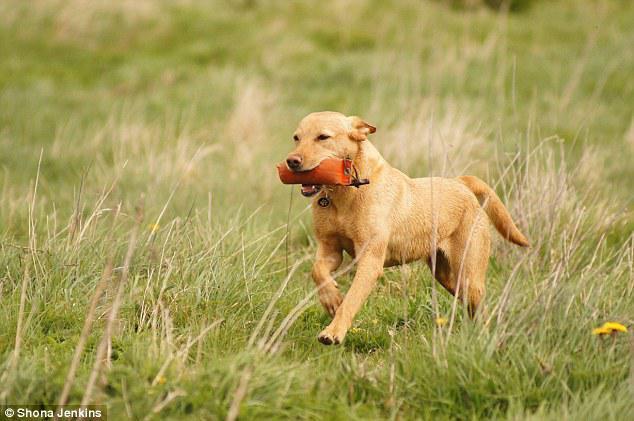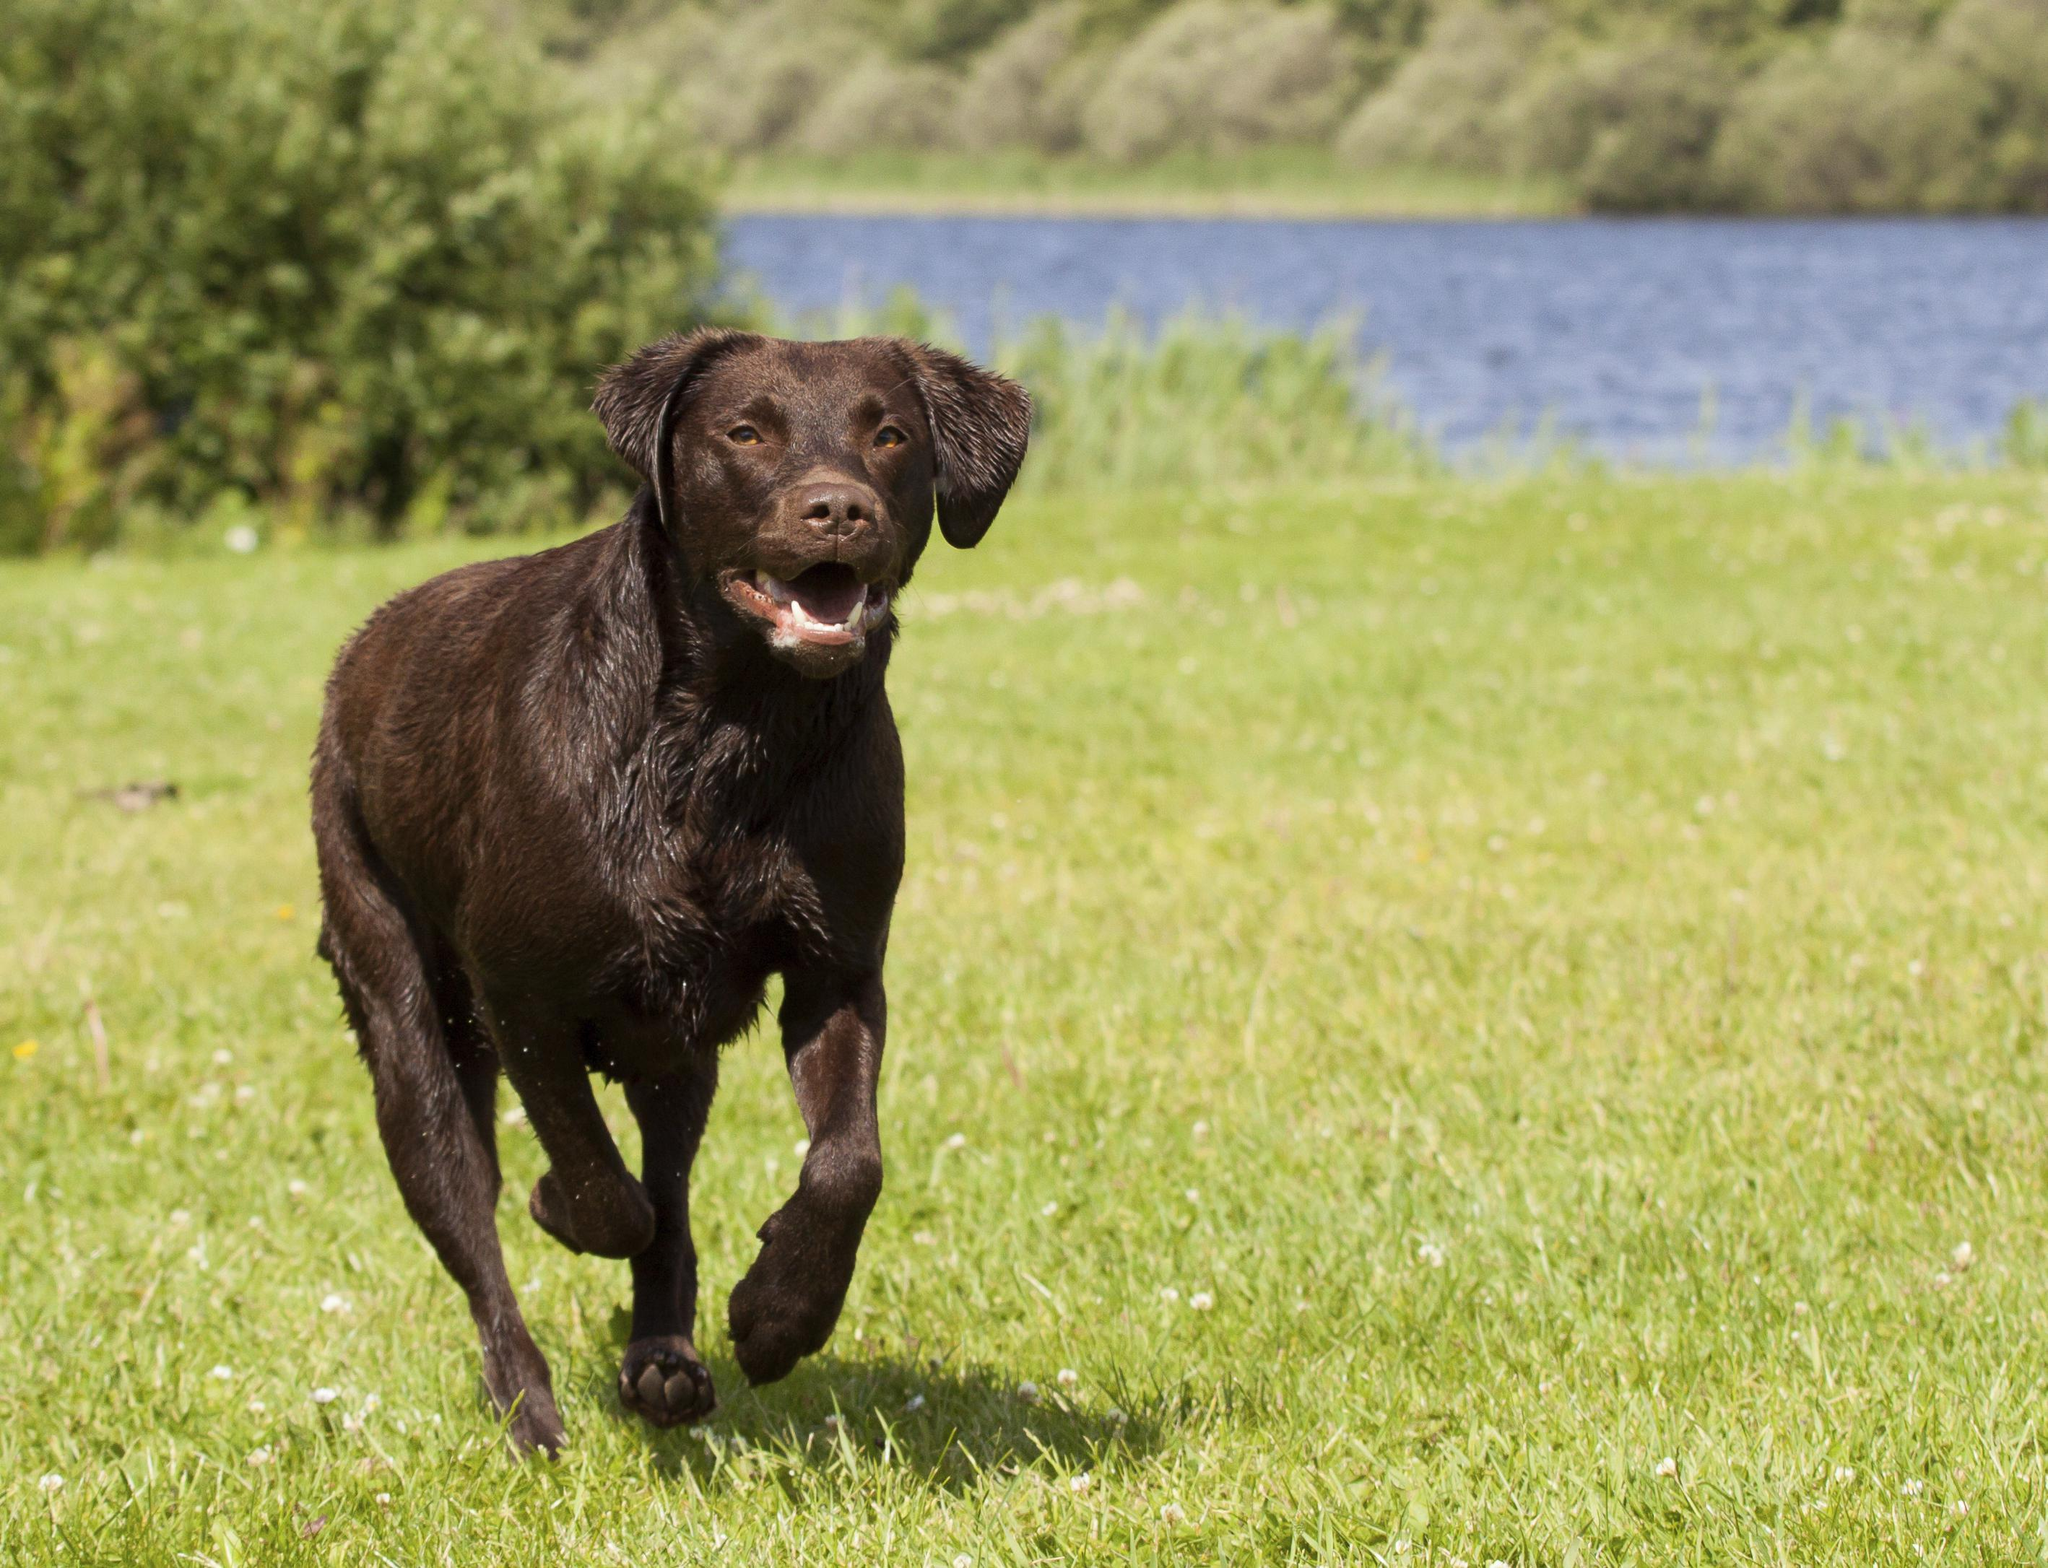The first image is the image on the left, the second image is the image on the right. Given the left and right images, does the statement "There are three black dogs in the grass." hold true? Answer yes or no. No. The first image is the image on the left, the second image is the image on the right. Analyze the images presented: Is the assertion "There are four dogs in total." valid? Answer yes or no. No. 